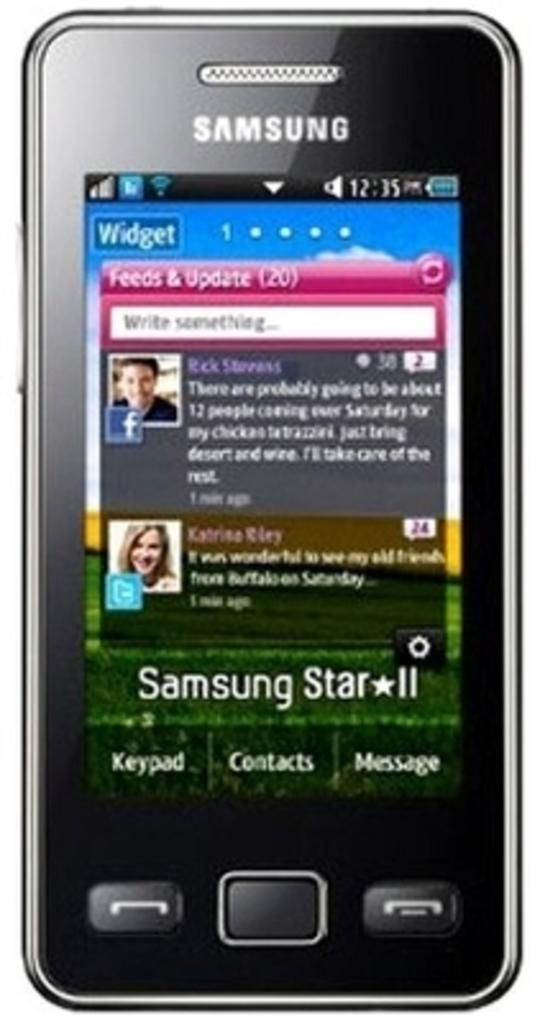<image>
Summarize the visual content of the image. A Samsung phone shows feeds and update on its screen 